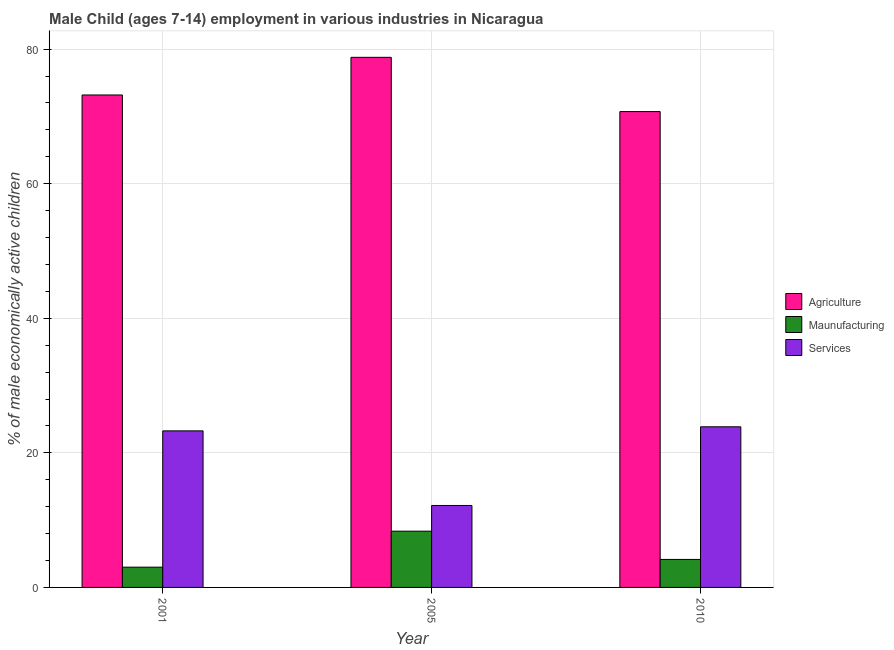Are the number of bars per tick equal to the number of legend labels?
Make the answer very short. Yes. How many bars are there on the 3rd tick from the left?
Provide a succinct answer. 3. How many bars are there on the 2nd tick from the right?
Your answer should be compact. 3. What is the percentage of economically active children in manufacturing in 2005?
Offer a terse response. 8.36. Across all years, what is the maximum percentage of economically active children in agriculture?
Offer a terse response. 78.78. Across all years, what is the minimum percentage of economically active children in services?
Provide a short and direct response. 12.18. In which year was the percentage of economically active children in services maximum?
Ensure brevity in your answer.  2010. In which year was the percentage of economically active children in services minimum?
Offer a terse response. 2005. What is the total percentage of economically active children in manufacturing in the graph?
Give a very brief answer. 15.53. What is the difference between the percentage of economically active children in manufacturing in 2001 and that in 2005?
Your answer should be very brief. -5.35. What is the difference between the percentage of economically active children in agriculture in 2010 and the percentage of economically active children in manufacturing in 2005?
Ensure brevity in your answer.  -8.06. What is the average percentage of economically active children in agriculture per year?
Your answer should be compact. 74.23. What is the ratio of the percentage of economically active children in manufacturing in 2001 to that in 2005?
Ensure brevity in your answer.  0.36. What is the difference between the highest and the second highest percentage of economically active children in manufacturing?
Provide a short and direct response. 4.2. What is the difference between the highest and the lowest percentage of economically active children in manufacturing?
Offer a terse response. 5.35. In how many years, is the percentage of economically active children in services greater than the average percentage of economically active children in services taken over all years?
Your answer should be very brief. 2. Is the sum of the percentage of economically active children in services in 2001 and 2005 greater than the maximum percentage of economically active children in manufacturing across all years?
Provide a short and direct response. Yes. What does the 2nd bar from the left in 2005 represents?
Your response must be concise. Maunufacturing. What does the 1st bar from the right in 2001 represents?
Offer a terse response. Services. Is it the case that in every year, the sum of the percentage of economically active children in agriculture and percentage of economically active children in manufacturing is greater than the percentage of economically active children in services?
Provide a short and direct response. Yes. How many years are there in the graph?
Ensure brevity in your answer.  3. What is the difference between two consecutive major ticks on the Y-axis?
Offer a very short reply. 20. Does the graph contain any zero values?
Your answer should be very brief. No. How many legend labels are there?
Offer a terse response. 3. What is the title of the graph?
Keep it short and to the point. Male Child (ages 7-14) employment in various industries in Nicaragua. What is the label or title of the Y-axis?
Offer a very short reply. % of male economically active children. What is the % of male economically active children of Agriculture in 2001?
Offer a terse response. 73.19. What is the % of male economically active children in Maunufacturing in 2001?
Your answer should be compact. 3.01. What is the % of male economically active children of Services in 2001?
Provide a succinct answer. 23.27. What is the % of male economically active children of Agriculture in 2005?
Your response must be concise. 78.78. What is the % of male economically active children of Maunufacturing in 2005?
Offer a very short reply. 8.36. What is the % of male economically active children in Services in 2005?
Offer a very short reply. 12.18. What is the % of male economically active children in Agriculture in 2010?
Provide a short and direct response. 70.72. What is the % of male economically active children in Maunufacturing in 2010?
Your answer should be very brief. 4.16. What is the % of male economically active children of Services in 2010?
Provide a succinct answer. 23.87. Across all years, what is the maximum % of male economically active children in Agriculture?
Ensure brevity in your answer.  78.78. Across all years, what is the maximum % of male economically active children in Maunufacturing?
Offer a very short reply. 8.36. Across all years, what is the maximum % of male economically active children of Services?
Offer a terse response. 23.87. Across all years, what is the minimum % of male economically active children in Agriculture?
Give a very brief answer. 70.72. Across all years, what is the minimum % of male economically active children of Maunufacturing?
Ensure brevity in your answer.  3.01. Across all years, what is the minimum % of male economically active children in Services?
Offer a very short reply. 12.18. What is the total % of male economically active children of Agriculture in the graph?
Ensure brevity in your answer.  222.69. What is the total % of male economically active children of Maunufacturing in the graph?
Offer a very short reply. 15.53. What is the total % of male economically active children of Services in the graph?
Offer a terse response. 59.32. What is the difference between the % of male economically active children in Agriculture in 2001 and that in 2005?
Your response must be concise. -5.59. What is the difference between the % of male economically active children in Maunufacturing in 2001 and that in 2005?
Provide a succinct answer. -5.35. What is the difference between the % of male economically active children of Services in 2001 and that in 2005?
Your answer should be compact. 11.09. What is the difference between the % of male economically active children in Agriculture in 2001 and that in 2010?
Offer a terse response. 2.47. What is the difference between the % of male economically active children in Maunufacturing in 2001 and that in 2010?
Make the answer very short. -1.15. What is the difference between the % of male economically active children in Services in 2001 and that in 2010?
Ensure brevity in your answer.  -0.6. What is the difference between the % of male economically active children of Agriculture in 2005 and that in 2010?
Ensure brevity in your answer.  8.06. What is the difference between the % of male economically active children of Services in 2005 and that in 2010?
Make the answer very short. -11.69. What is the difference between the % of male economically active children in Agriculture in 2001 and the % of male economically active children in Maunufacturing in 2005?
Your answer should be very brief. 64.83. What is the difference between the % of male economically active children of Agriculture in 2001 and the % of male economically active children of Services in 2005?
Offer a terse response. 61.01. What is the difference between the % of male economically active children of Maunufacturing in 2001 and the % of male economically active children of Services in 2005?
Ensure brevity in your answer.  -9.17. What is the difference between the % of male economically active children in Agriculture in 2001 and the % of male economically active children in Maunufacturing in 2010?
Your response must be concise. 69.03. What is the difference between the % of male economically active children in Agriculture in 2001 and the % of male economically active children in Services in 2010?
Your answer should be compact. 49.32. What is the difference between the % of male economically active children of Maunufacturing in 2001 and the % of male economically active children of Services in 2010?
Provide a succinct answer. -20.86. What is the difference between the % of male economically active children of Agriculture in 2005 and the % of male economically active children of Maunufacturing in 2010?
Make the answer very short. 74.62. What is the difference between the % of male economically active children in Agriculture in 2005 and the % of male economically active children in Services in 2010?
Provide a succinct answer. 54.91. What is the difference between the % of male economically active children of Maunufacturing in 2005 and the % of male economically active children of Services in 2010?
Provide a succinct answer. -15.51. What is the average % of male economically active children of Agriculture per year?
Provide a succinct answer. 74.23. What is the average % of male economically active children in Maunufacturing per year?
Your response must be concise. 5.18. What is the average % of male economically active children in Services per year?
Provide a short and direct response. 19.77. In the year 2001, what is the difference between the % of male economically active children in Agriculture and % of male economically active children in Maunufacturing?
Give a very brief answer. 70.17. In the year 2001, what is the difference between the % of male economically active children in Agriculture and % of male economically active children in Services?
Your answer should be compact. 49.92. In the year 2001, what is the difference between the % of male economically active children of Maunufacturing and % of male economically active children of Services?
Keep it short and to the point. -20.25. In the year 2005, what is the difference between the % of male economically active children of Agriculture and % of male economically active children of Maunufacturing?
Your answer should be compact. 70.42. In the year 2005, what is the difference between the % of male economically active children in Agriculture and % of male economically active children in Services?
Make the answer very short. 66.6. In the year 2005, what is the difference between the % of male economically active children in Maunufacturing and % of male economically active children in Services?
Make the answer very short. -3.82. In the year 2010, what is the difference between the % of male economically active children of Agriculture and % of male economically active children of Maunufacturing?
Provide a succinct answer. 66.56. In the year 2010, what is the difference between the % of male economically active children of Agriculture and % of male economically active children of Services?
Keep it short and to the point. 46.85. In the year 2010, what is the difference between the % of male economically active children of Maunufacturing and % of male economically active children of Services?
Your answer should be compact. -19.71. What is the ratio of the % of male economically active children in Agriculture in 2001 to that in 2005?
Your answer should be very brief. 0.93. What is the ratio of the % of male economically active children of Maunufacturing in 2001 to that in 2005?
Ensure brevity in your answer.  0.36. What is the ratio of the % of male economically active children in Services in 2001 to that in 2005?
Keep it short and to the point. 1.91. What is the ratio of the % of male economically active children of Agriculture in 2001 to that in 2010?
Your response must be concise. 1.03. What is the ratio of the % of male economically active children in Maunufacturing in 2001 to that in 2010?
Provide a succinct answer. 0.72. What is the ratio of the % of male economically active children of Services in 2001 to that in 2010?
Provide a succinct answer. 0.97. What is the ratio of the % of male economically active children of Agriculture in 2005 to that in 2010?
Keep it short and to the point. 1.11. What is the ratio of the % of male economically active children of Maunufacturing in 2005 to that in 2010?
Your response must be concise. 2.01. What is the ratio of the % of male economically active children in Services in 2005 to that in 2010?
Your answer should be very brief. 0.51. What is the difference between the highest and the second highest % of male economically active children in Agriculture?
Your answer should be very brief. 5.59. What is the difference between the highest and the second highest % of male economically active children of Maunufacturing?
Your answer should be very brief. 4.2. What is the difference between the highest and the second highest % of male economically active children in Services?
Your response must be concise. 0.6. What is the difference between the highest and the lowest % of male economically active children in Agriculture?
Keep it short and to the point. 8.06. What is the difference between the highest and the lowest % of male economically active children in Maunufacturing?
Keep it short and to the point. 5.35. What is the difference between the highest and the lowest % of male economically active children in Services?
Offer a terse response. 11.69. 